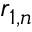<formula> <loc_0><loc_0><loc_500><loc_500>r _ { 1 , n }</formula> 